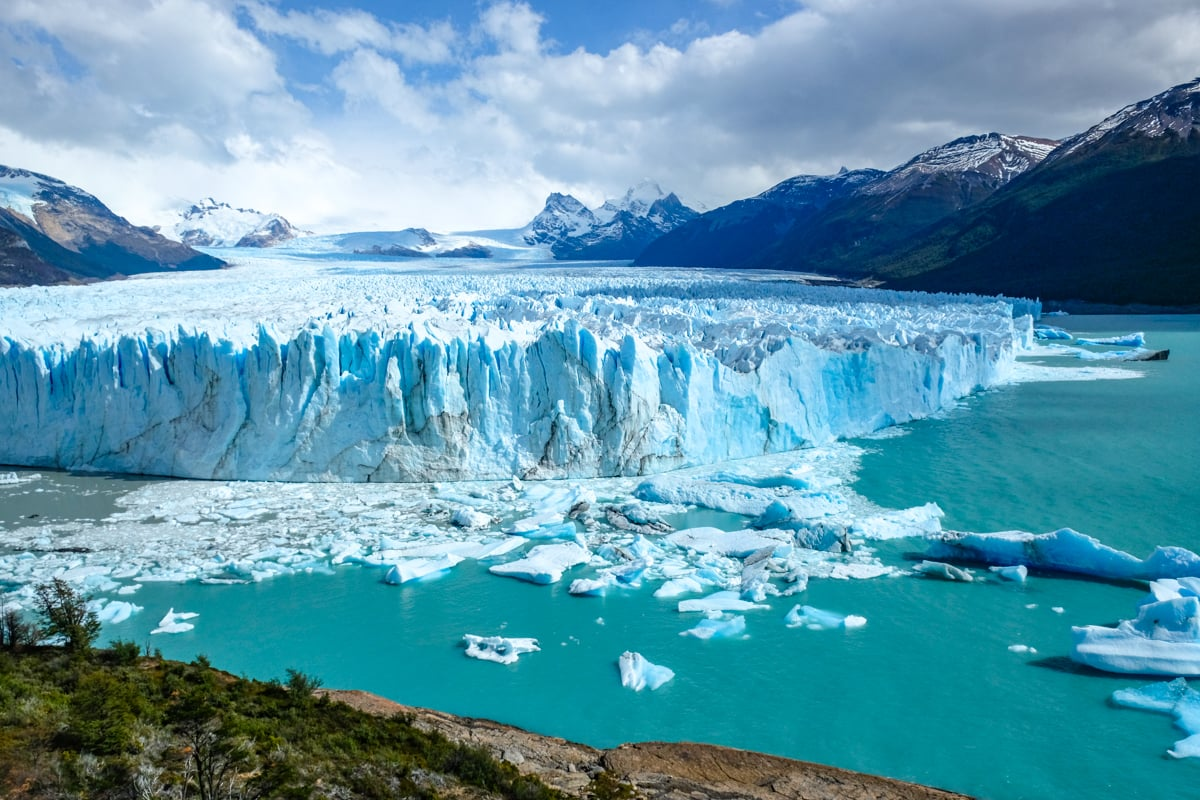Describe the feelings this scene might evoke in a person visiting it for the first time. Visiting for the first time, one might feel a profound sense of awe and insignificance in the face of nature's grandeur. The sheer scale and beauty of the Perito Moreno Glacier can evoke feelings of wonder, tranquility, and a deep appreciation for the natural world. The pristine blue ice, surrounded by the serenity of the turquoise water and snow-capped mountains, creates a surreal experience that is both humbling and meditative. What details from the image stand out the most? Several details in the image stand out prominently: the bright blue hues of the glacier ice, the intricate patterns and textures of the ice face, and the scattered icebergs floating in the turquoise water. The contrast between the glacier’s cold blues and the vibrant greens of the surrounding vegetation is striking. Additionally, the snow-capped mountains in the background add depth to the scene, making the landscape feel expansive and majestic. The clear blue sky dotted with clouds completes the picturesque view. 